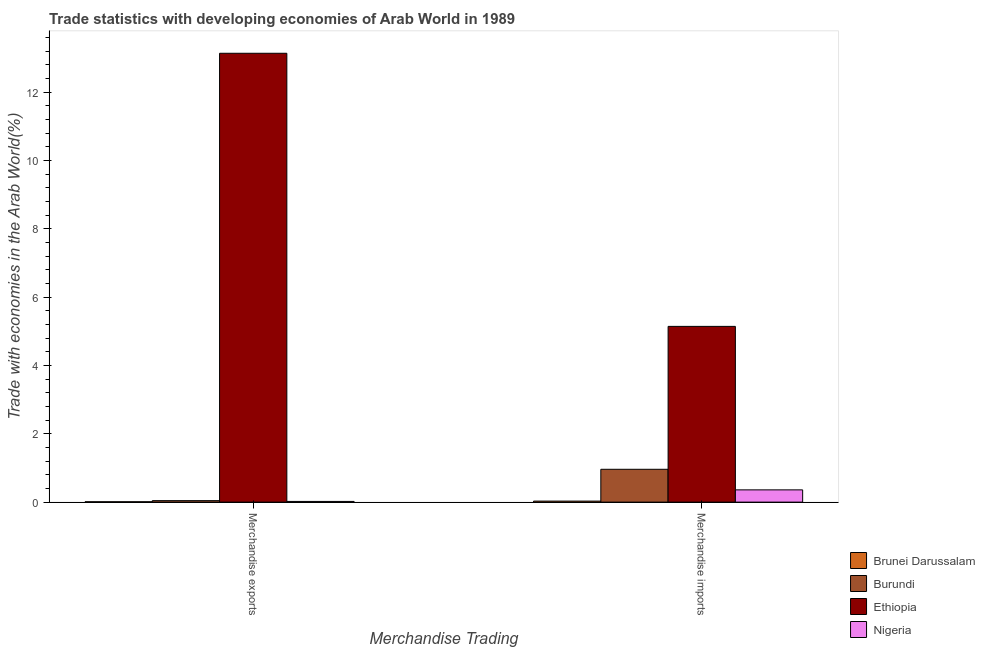How many different coloured bars are there?
Ensure brevity in your answer.  4. Are the number of bars per tick equal to the number of legend labels?
Ensure brevity in your answer.  Yes. Are the number of bars on each tick of the X-axis equal?
Your answer should be compact. Yes. What is the label of the 2nd group of bars from the left?
Ensure brevity in your answer.  Merchandise imports. What is the merchandise exports in Nigeria?
Offer a terse response. 0.02. Across all countries, what is the maximum merchandise exports?
Give a very brief answer. 13.14. Across all countries, what is the minimum merchandise imports?
Give a very brief answer. 0.03. In which country was the merchandise exports maximum?
Provide a succinct answer. Ethiopia. In which country was the merchandise imports minimum?
Keep it short and to the point. Brunei Darussalam. What is the total merchandise imports in the graph?
Your answer should be compact. 6.49. What is the difference between the merchandise exports in Nigeria and that in Ethiopia?
Offer a terse response. -13.12. What is the difference between the merchandise imports in Nigeria and the merchandise exports in Burundi?
Your answer should be very brief. 0.32. What is the average merchandise exports per country?
Offer a very short reply. 3.3. What is the difference between the merchandise exports and merchandise imports in Burundi?
Your answer should be compact. -0.92. In how many countries, is the merchandise imports greater than 1.6 %?
Keep it short and to the point. 1. What is the ratio of the merchandise imports in Brunei Darussalam to that in Nigeria?
Offer a terse response. 0.08. In how many countries, is the merchandise exports greater than the average merchandise exports taken over all countries?
Provide a short and direct response. 1. What does the 1st bar from the left in Merchandise imports represents?
Provide a succinct answer. Brunei Darussalam. What does the 3rd bar from the right in Merchandise imports represents?
Your response must be concise. Burundi. How many bars are there?
Provide a succinct answer. 8. How many countries are there in the graph?
Ensure brevity in your answer.  4. Are the values on the major ticks of Y-axis written in scientific E-notation?
Offer a terse response. No. How many legend labels are there?
Your answer should be compact. 4. What is the title of the graph?
Provide a short and direct response. Trade statistics with developing economies of Arab World in 1989. Does "Myanmar" appear as one of the legend labels in the graph?
Ensure brevity in your answer.  No. What is the label or title of the X-axis?
Ensure brevity in your answer.  Merchandise Trading. What is the label or title of the Y-axis?
Provide a succinct answer. Trade with economies in the Arab World(%). What is the Trade with economies in the Arab World(%) of Brunei Darussalam in Merchandise exports?
Your response must be concise. 0.01. What is the Trade with economies in the Arab World(%) in Burundi in Merchandise exports?
Your answer should be very brief. 0.04. What is the Trade with economies in the Arab World(%) in Ethiopia in Merchandise exports?
Offer a very short reply. 13.14. What is the Trade with economies in the Arab World(%) of Nigeria in Merchandise exports?
Provide a short and direct response. 0.02. What is the Trade with economies in the Arab World(%) in Brunei Darussalam in Merchandise imports?
Offer a terse response. 0.03. What is the Trade with economies in the Arab World(%) of Burundi in Merchandise imports?
Provide a succinct answer. 0.96. What is the Trade with economies in the Arab World(%) of Ethiopia in Merchandise imports?
Offer a very short reply. 5.14. What is the Trade with economies in the Arab World(%) of Nigeria in Merchandise imports?
Ensure brevity in your answer.  0.36. Across all Merchandise Trading, what is the maximum Trade with economies in the Arab World(%) in Brunei Darussalam?
Make the answer very short. 0.03. Across all Merchandise Trading, what is the maximum Trade with economies in the Arab World(%) in Burundi?
Offer a terse response. 0.96. Across all Merchandise Trading, what is the maximum Trade with economies in the Arab World(%) in Ethiopia?
Ensure brevity in your answer.  13.14. Across all Merchandise Trading, what is the maximum Trade with economies in the Arab World(%) in Nigeria?
Provide a succinct answer. 0.36. Across all Merchandise Trading, what is the minimum Trade with economies in the Arab World(%) of Brunei Darussalam?
Provide a short and direct response. 0.01. Across all Merchandise Trading, what is the minimum Trade with economies in the Arab World(%) in Burundi?
Provide a short and direct response. 0.04. Across all Merchandise Trading, what is the minimum Trade with economies in the Arab World(%) of Ethiopia?
Provide a short and direct response. 5.14. Across all Merchandise Trading, what is the minimum Trade with economies in the Arab World(%) in Nigeria?
Offer a terse response. 0.02. What is the total Trade with economies in the Arab World(%) of Brunei Darussalam in the graph?
Give a very brief answer. 0.04. What is the total Trade with economies in the Arab World(%) in Burundi in the graph?
Provide a succinct answer. 1. What is the total Trade with economies in the Arab World(%) in Ethiopia in the graph?
Provide a succinct answer. 18.28. What is the total Trade with economies in the Arab World(%) of Nigeria in the graph?
Your answer should be compact. 0.38. What is the difference between the Trade with economies in the Arab World(%) of Brunei Darussalam in Merchandise exports and that in Merchandise imports?
Give a very brief answer. -0.02. What is the difference between the Trade with economies in the Arab World(%) in Burundi in Merchandise exports and that in Merchandise imports?
Your answer should be very brief. -0.92. What is the difference between the Trade with economies in the Arab World(%) of Ethiopia in Merchandise exports and that in Merchandise imports?
Your response must be concise. 7.99. What is the difference between the Trade with economies in the Arab World(%) in Nigeria in Merchandise exports and that in Merchandise imports?
Offer a very short reply. -0.34. What is the difference between the Trade with economies in the Arab World(%) in Brunei Darussalam in Merchandise exports and the Trade with economies in the Arab World(%) in Burundi in Merchandise imports?
Offer a terse response. -0.95. What is the difference between the Trade with economies in the Arab World(%) in Brunei Darussalam in Merchandise exports and the Trade with economies in the Arab World(%) in Ethiopia in Merchandise imports?
Your answer should be very brief. -5.13. What is the difference between the Trade with economies in the Arab World(%) in Brunei Darussalam in Merchandise exports and the Trade with economies in the Arab World(%) in Nigeria in Merchandise imports?
Ensure brevity in your answer.  -0.35. What is the difference between the Trade with economies in the Arab World(%) of Burundi in Merchandise exports and the Trade with economies in the Arab World(%) of Ethiopia in Merchandise imports?
Keep it short and to the point. -5.1. What is the difference between the Trade with economies in the Arab World(%) in Burundi in Merchandise exports and the Trade with economies in the Arab World(%) in Nigeria in Merchandise imports?
Provide a succinct answer. -0.32. What is the difference between the Trade with economies in the Arab World(%) of Ethiopia in Merchandise exports and the Trade with economies in the Arab World(%) of Nigeria in Merchandise imports?
Provide a succinct answer. 12.78. What is the average Trade with economies in the Arab World(%) in Brunei Darussalam per Merchandise Trading?
Offer a very short reply. 0.02. What is the average Trade with economies in the Arab World(%) in Burundi per Merchandise Trading?
Offer a very short reply. 0.5. What is the average Trade with economies in the Arab World(%) of Ethiopia per Merchandise Trading?
Ensure brevity in your answer.  9.14. What is the average Trade with economies in the Arab World(%) in Nigeria per Merchandise Trading?
Make the answer very short. 0.19. What is the difference between the Trade with economies in the Arab World(%) in Brunei Darussalam and Trade with economies in the Arab World(%) in Burundi in Merchandise exports?
Your answer should be very brief. -0.03. What is the difference between the Trade with economies in the Arab World(%) of Brunei Darussalam and Trade with economies in the Arab World(%) of Ethiopia in Merchandise exports?
Your response must be concise. -13.12. What is the difference between the Trade with economies in the Arab World(%) of Brunei Darussalam and Trade with economies in the Arab World(%) of Nigeria in Merchandise exports?
Make the answer very short. -0.01. What is the difference between the Trade with economies in the Arab World(%) in Burundi and Trade with economies in the Arab World(%) in Ethiopia in Merchandise exports?
Ensure brevity in your answer.  -13.09. What is the difference between the Trade with economies in the Arab World(%) in Burundi and Trade with economies in the Arab World(%) in Nigeria in Merchandise exports?
Give a very brief answer. 0.02. What is the difference between the Trade with economies in the Arab World(%) of Ethiopia and Trade with economies in the Arab World(%) of Nigeria in Merchandise exports?
Give a very brief answer. 13.12. What is the difference between the Trade with economies in the Arab World(%) of Brunei Darussalam and Trade with economies in the Arab World(%) of Burundi in Merchandise imports?
Your answer should be very brief. -0.93. What is the difference between the Trade with economies in the Arab World(%) in Brunei Darussalam and Trade with economies in the Arab World(%) in Ethiopia in Merchandise imports?
Ensure brevity in your answer.  -5.11. What is the difference between the Trade with economies in the Arab World(%) of Brunei Darussalam and Trade with economies in the Arab World(%) of Nigeria in Merchandise imports?
Provide a succinct answer. -0.33. What is the difference between the Trade with economies in the Arab World(%) in Burundi and Trade with economies in the Arab World(%) in Ethiopia in Merchandise imports?
Your answer should be compact. -4.18. What is the difference between the Trade with economies in the Arab World(%) in Burundi and Trade with economies in the Arab World(%) in Nigeria in Merchandise imports?
Keep it short and to the point. 0.6. What is the difference between the Trade with economies in the Arab World(%) of Ethiopia and Trade with economies in the Arab World(%) of Nigeria in Merchandise imports?
Provide a succinct answer. 4.78. What is the ratio of the Trade with economies in the Arab World(%) in Brunei Darussalam in Merchandise exports to that in Merchandise imports?
Ensure brevity in your answer.  0.36. What is the ratio of the Trade with economies in the Arab World(%) of Burundi in Merchandise exports to that in Merchandise imports?
Your answer should be very brief. 0.04. What is the ratio of the Trade with economies in the Arab World(%) in Ethiopia in Merchandise exports to that in Merchandise imports?
Your response must be concise. 2.55. What is the ratio of the Trade with economies in the Arab World(%) in Nigeria in Merchandise exports to that in Merchandise imports?
Keep it short and to the point. 0.06. What is the difference between the highest and the second highest Trade with economies in the Arab World(%) in Brunei Darussalam?
Provide a succinct answer. 0.02. What is the difference between the highest and the second highest Trade with economies in the Arab World(%) of Burundi?
Your answer should be compact. 0.92. What is the difference between the highest and the second highest Trade with economies in the Arab World(%) of Ethiopia?
Give a very brief answer. 7.99. What is the difference between the highest and the second highest Trade with economies in the Arab World(%) in Nigeria?
Provide a short and direct response. 0.34. What is the difference between the highest and the lowest Trade with economies in the Arab World(%) in Brunei Darussalam?
Keep it short and to the point. 0.02. What is the difference between the highest and the lowest Trade with economies in the Arab World(%) of Burundi?
Make the answer very short. 0.92. What is the difference between the highest and the lowest Trade with economies in the Arab World(%) of Ethiopia?
Your response must be concise. 7.99. What is the difference between the highest and the lowest Trade with economies in the Arab World(%) of Nigeria?
Your response must be concise. 0.34. 